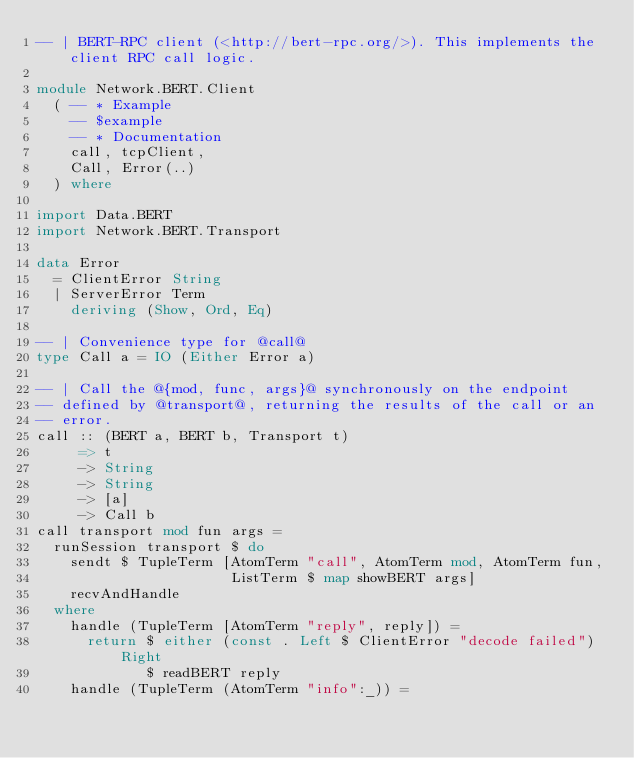Convert code to text. <code><loc_0><loc_0><loc_500><loc_500><_Haskell_>-- | BERT-RPC client (<http://bert-rpc.org/>). This implements the client RPC call logic.

module Network.BERT.Client
  ( -- * Example
    -- $example
    -- * Documentation
    call, tcpClient,
    Call, Error(..)
  ) where

import Data.BERT
import Network.BERT.Transport

data Error
  = ClientError String
  | ServerError Term
    deriving (Show, Ord, Eq)

-- | Convenience type for @call@
type Call a = IO (Either Error a)

-- | Call the @{mod, func, args}@ synchronously on the endpoint
-- defined by @transport@, returning the results of the call or an
-- error.
call :: (BERT a, BERT b, Transport t)
     => t
     -> String
     -> String
     -> [a]
     -> Call b
call transport mod fun args =
  runSession transport $ do
    sendt $ TupleTerm [AtomTerm "call", AtomTerm mod, AtomTerm fun,
                       ListTerm $ map showBERT args]
    recvAndHandle
  where
    handle (TupleTerm [AtomTerm "reply", reply]) =
      return $ either (const . Left $ ClientError "decode failed") Right
             $ readBERT reply
    handle (TupleTerm (AtomTerm "info":_)) =</code> 